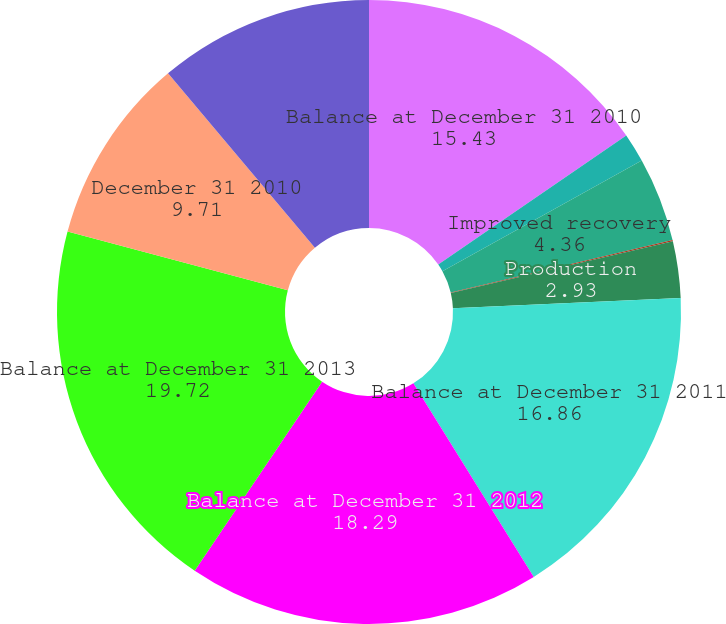Convert chart to OTSL. <chart><loc_0><loc_0><loc_500><loc_500><pie_chart><fcel>Balance at December 31 2010<fcel>Revisions of previous<fcel>Improved recovery<fcel>Extensions and discoveries<fcel>Production<fcel>Balance at December 31 2011<fcel>Balance at December 31 2012<fcel>Balance at December 31 2013<fcel>December 31 2010<fcel>December 31 2011<nl><fcel>15.43%<fcel>1.5%<fcel>4.36%<fcel>0.07%<fcel>2.93%<fcel>16.86%<fcel>18.29%<fcel>19.72%<fcel>9.71%<fcel>11.14%<nl></chart> 